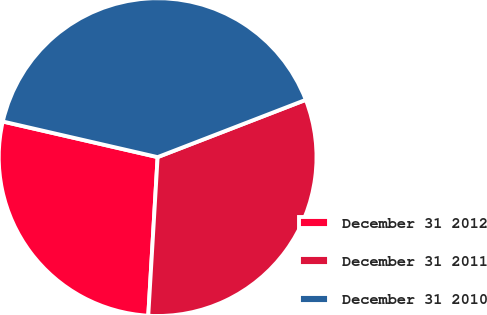Convert chart to OTSL. <chart><loc_0><loc_0><loc_500><loc_500><pie_chart><fcel>December 31 2012<fcel>December 31 2011<fcel>December 31 2010<nl><fcel>27.66%<fcel>31.81%<fcel>40.53%<nl></chart> 